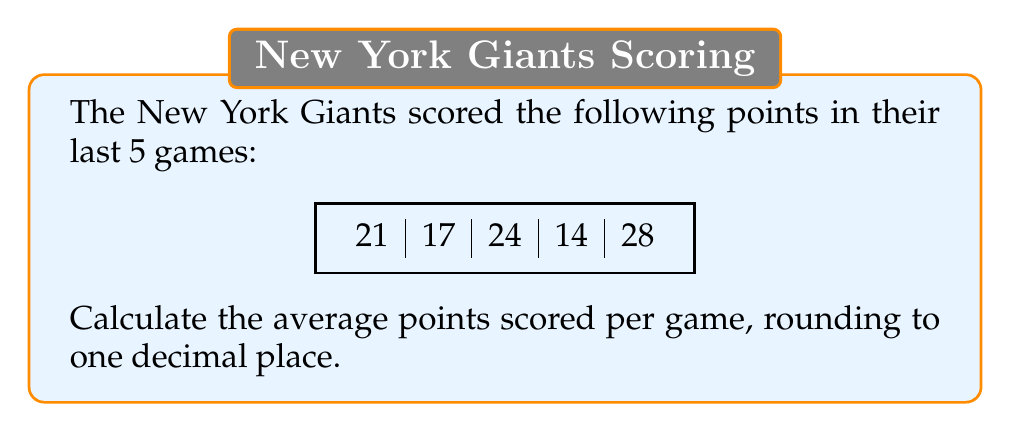Provide a solution to this math problem. To calculate the average points scored per game, we need to follow these steps:

1. Add up all the points scored:
   $$21 + 17 + 24 + 14 + 28 = 104$$

2. Count the total number of games:
   There are 5 games in total.

3. Divide the total points by the number of games:
   $$\frac{104}{5} = 20.8$$

4. Round the result to one decimal place:
   20.8 is already rounded to one decimal place, so no further rounding is needed.

Therefore, the average points scored per game by the New York Giants in these 5 games is 20.8 points.
Answer: $20.8$ points 